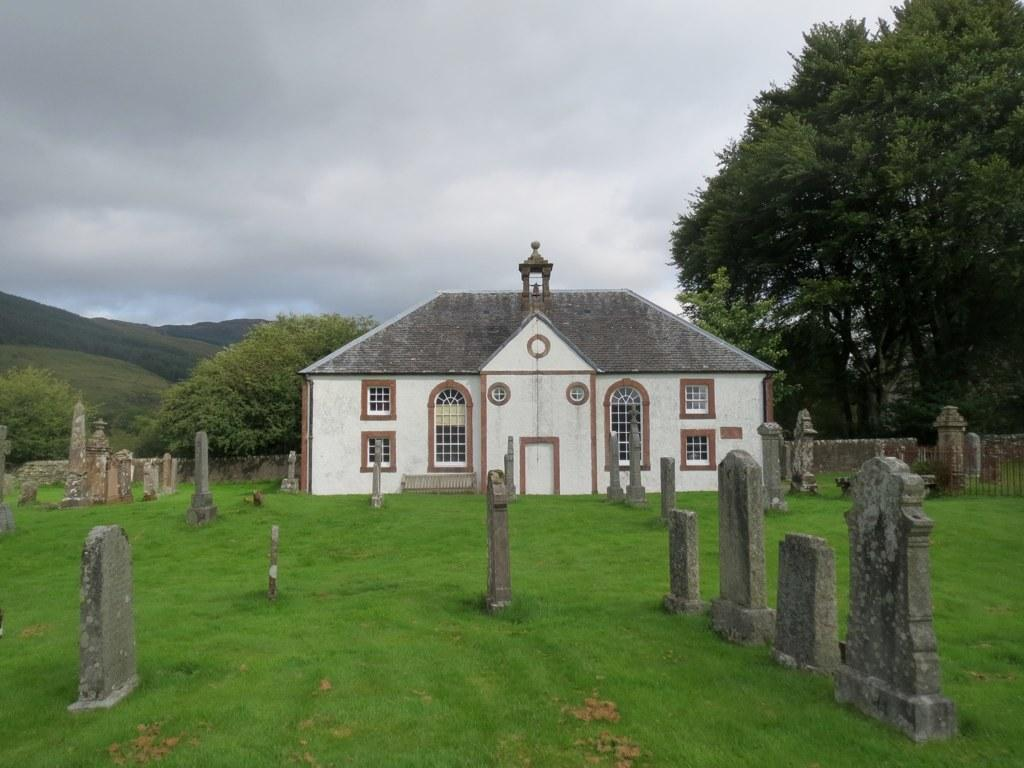What can be seen in the sky in the image? Clouds are visible in the image. What type of natural features are present in the image? Hills and trees are present in the image. What type of vegetation is visible in the image? Grass is visible in the image. What type of man-made structures can be seen in the image? There is a building with windows in the image. What type of boundary is present in the image? There is a compound wall in the image. What other objects can be seen in the image? There are headstones and a few other objects in the image. What type of appliance can be seen in the image? There is no appliance present in the image. How many trains are visible in the image? There are no trains present in the image. 